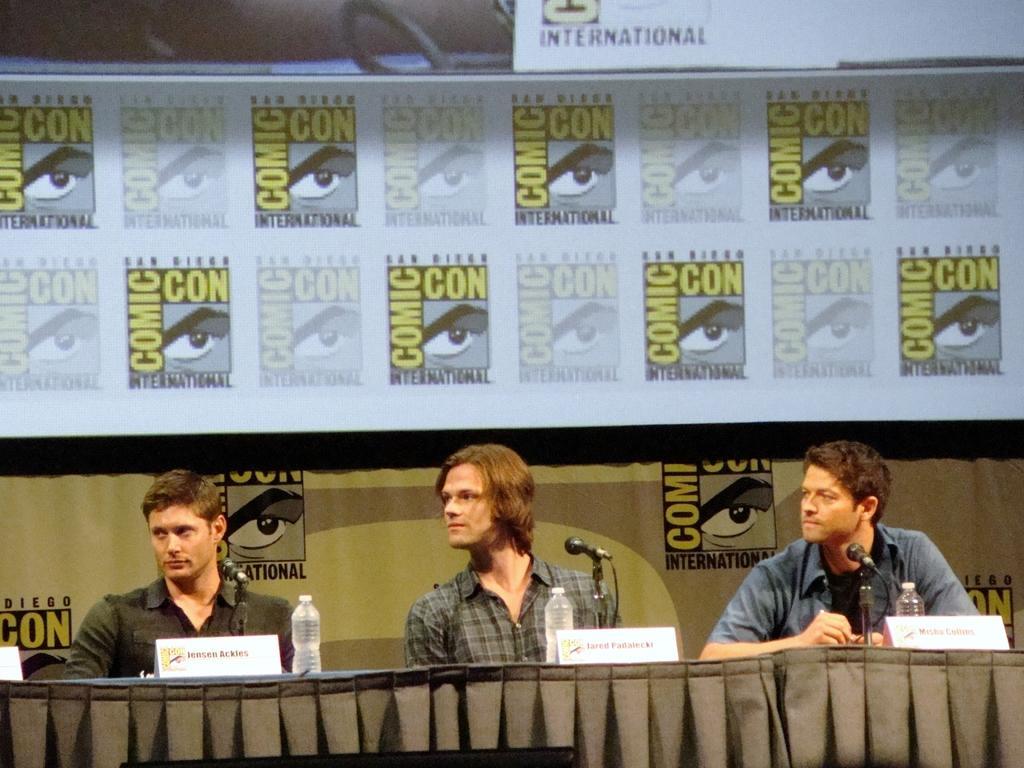How would you summarize this image in a sentence or two? In this image I can see three men are sitting in front of the table which is covered with a cloth. On the table, I can see few bottles, mike and name boards. These three men are looking at the left side. In the background, I can see a banner on which I can see some text. 